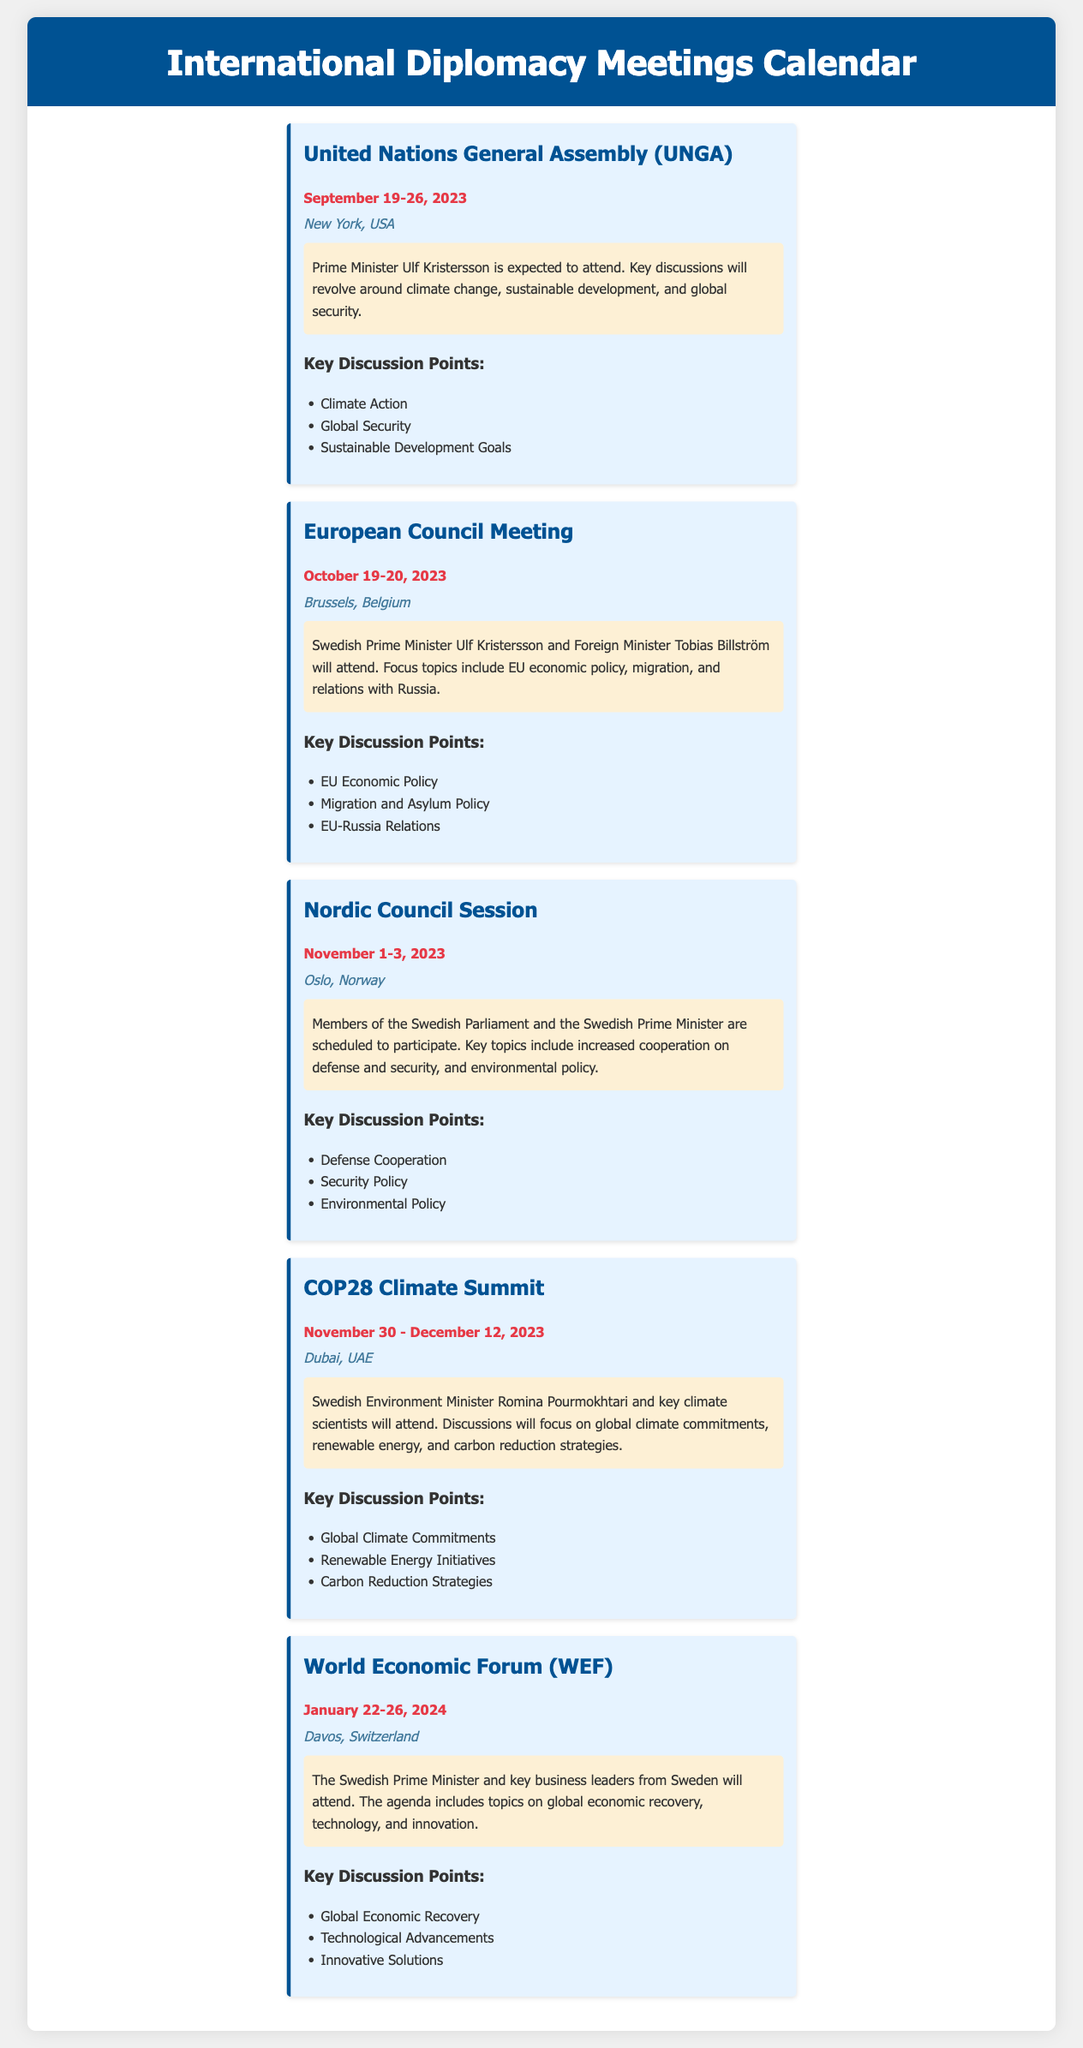What is the date range for the COP28 Climate Summit? The COP28 Climate Summit is scheduled to occur from November 30 to December 12, 2023, as mentioned in the document.
Answer: November 30 - December 12, 2023 Who will represent Sweden at the United Nations General Assembly? The document states that Prime Minister Ulf Kristersson is expected to attend the UNGA on behalf of Sweden.
Answer: Ulf Kristersson What is the location of the European Council Meeting? The document specifies that the European Council Meeting will take place in Brussels, Belgium.
Answer: Brussels, Belgium What are the key discussion points for the Nordic Council Session? The document lists Defense Cooperation, Security Policy, and Environmental Policy as the key discussion points for this session.
Answer: Defense Cooperation, Security Policy, Environmental Policy How many days will the World Economic Forum last? The document indicates that the World Economic Forum will run from January 22 to January 26, 2024, which is a total of 5 days.
Answer: 5 days Which Swedish minister will attend the COP28 Climate Summit? The document mentions that the Swedish Environment Minister Romina Pourmokhtari will attend the COP28 Climate Summit.
Answer: Romina Pourmokhtari What are the focus topics for the European Council Meeting? The document highlights EU Economic Policy, Migration, and Asylum Policy as focus topics during the European Council Meeting.
Answer: EU Economic Policy, Migration, Asylum Policy When is the Nordic Council Session scheduled? As per the document, the Nordic Council Session is scheduled for November 1-3, 2023.
Answer: November 1-3, 2023 What is the primary focus of discussions at the COP28 Climate Summit? The document lists global climate commitments, renewable energy, and carbon reduction strategies as the primary focuses at COP28.
Answer: Global climate commitments, renewable energy, carbon reduction strategies 